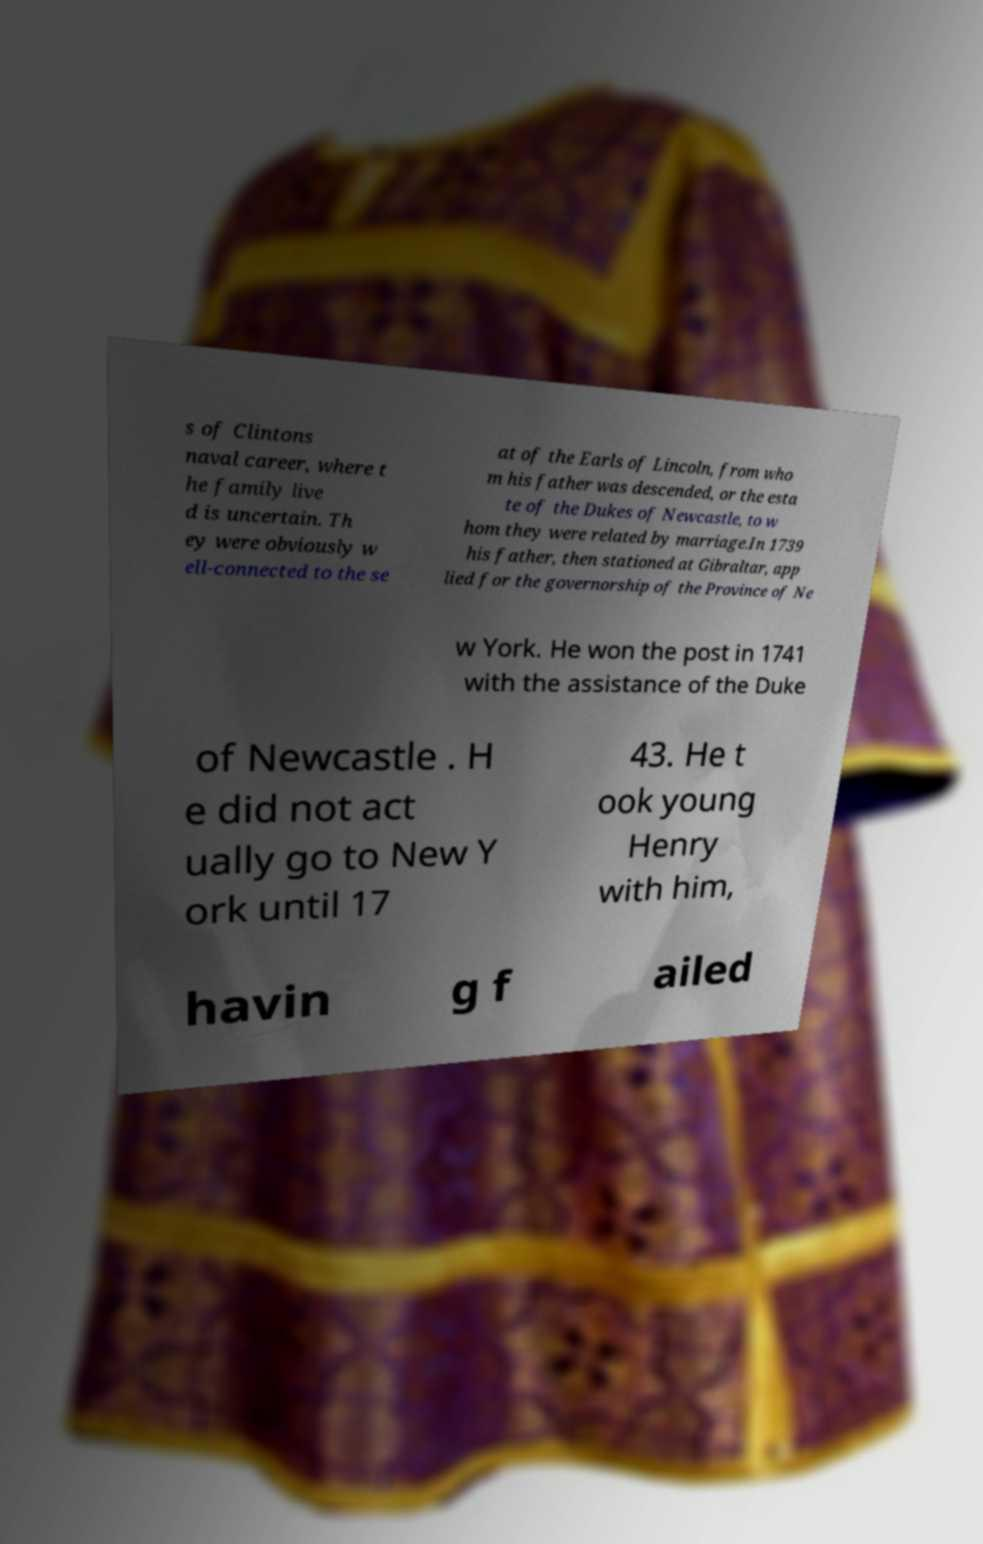Please read and relay the text visible in this image. What does it say? s of Clintons naval career, where t he family live d is uncertain. Th ey were obviously w ell-connected to the se at of the Earls of Lincoln, from who m his father was descended, or the esta te of the Dukes of Newcastle, to w hom they were related by marriage.In 1739 his father, then stationed at Gibraltar, app lied for the governorship of the Province of Ne w York. He won the post in 1741 with the assistance of the Duke of Newcastle . H e did not act ually go to New Y ork until 17 43. He t ook young Henry with him, havin g f ailed 